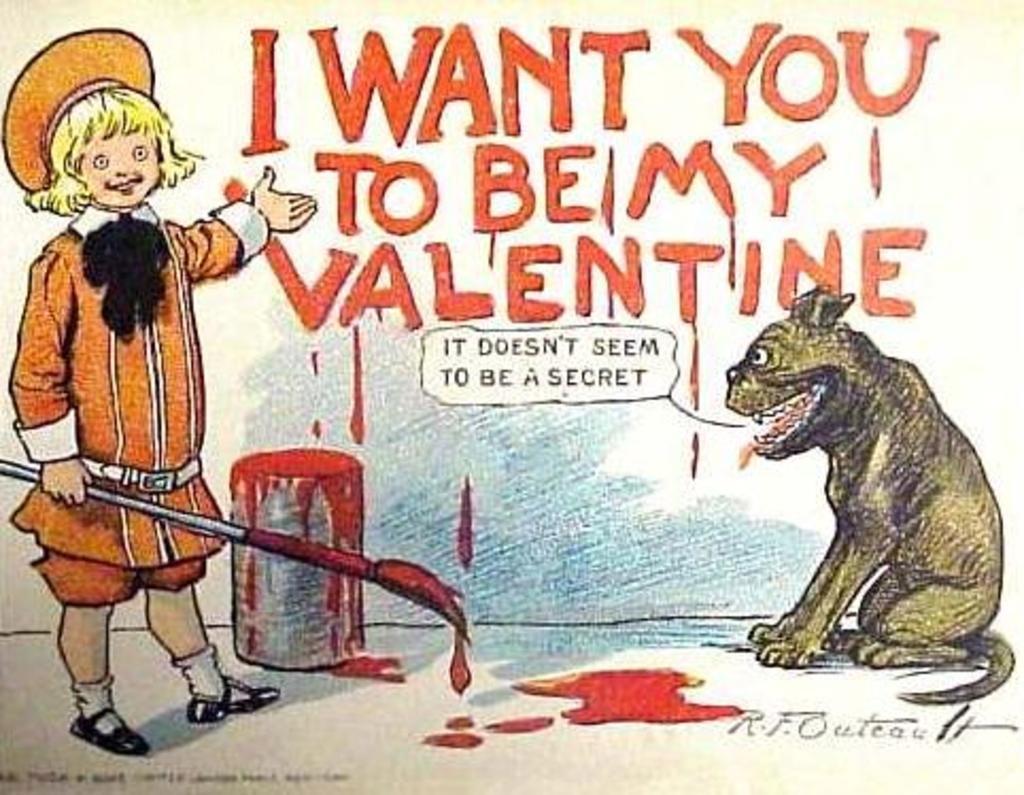How would you summarize this image in a sentence or two? This image consists of a poster i which there is a dog and a person holding a brush. In the background, there is a wall on which there is a text. 